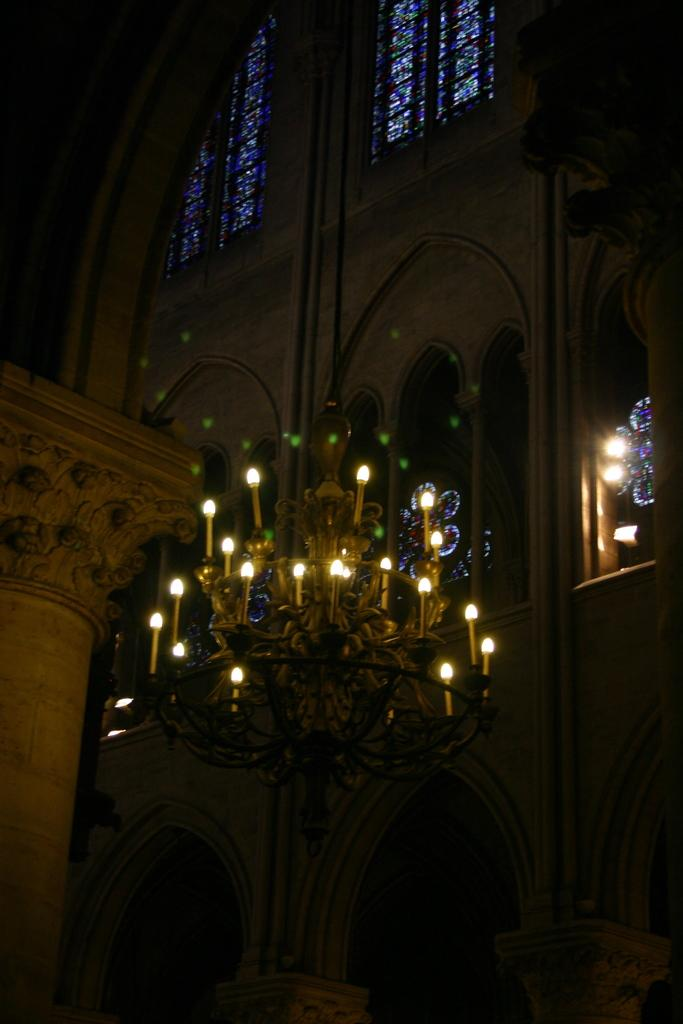What type of location is depicted in the image? The image shows the inside view of a building. What type of lighting fixture is visible in the image? There is a chandelier in the image. What architectural features can be seen in the image? Pillars are present in the image. What structural elements are visible in the image? Walls are visible in the image. What type of objects are made of glass in the image? Glass objects are in the image. What type of illumination is present in the image? Lights are present in the image. What type of chin can be seen on the jellyfish in the image? There are no jellyfish present in the image, and therefore no chins can be observed. What type of home is depicted in the image? The image does not show a home; it shows the inside view of a building. 